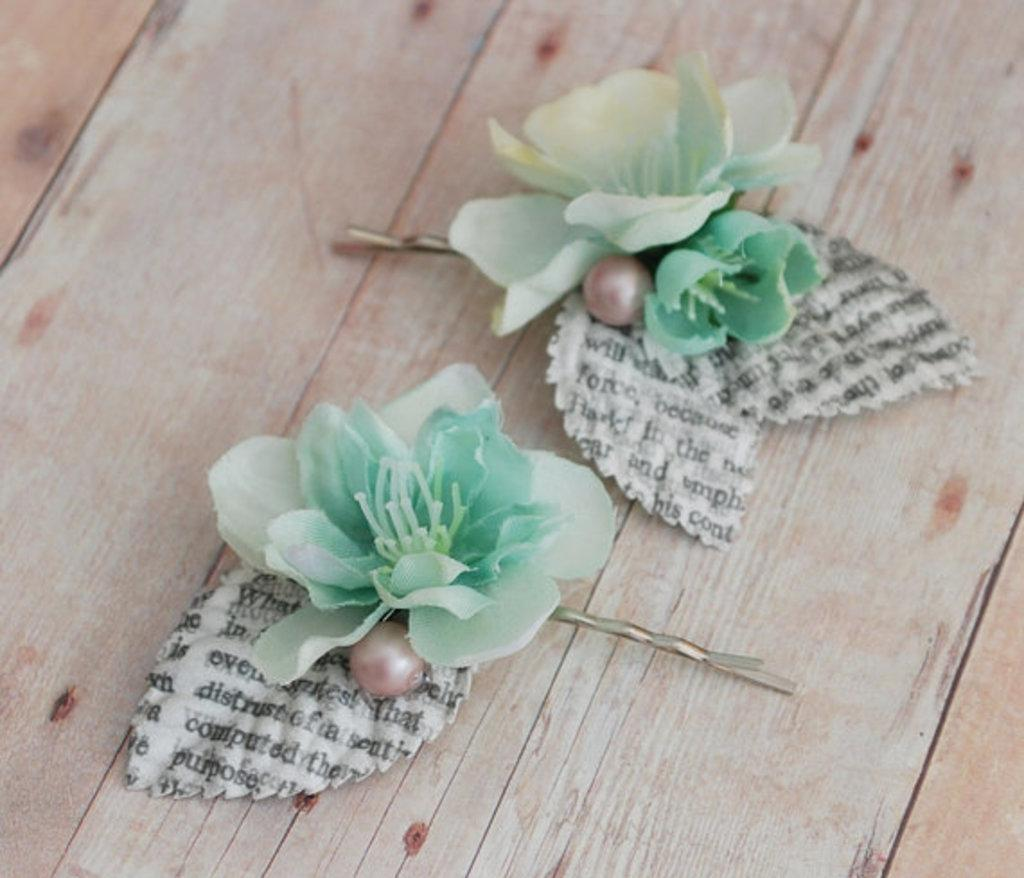What type of hair accessory is shown in the image? There are flower model hair pins in the image. Where are the hair pins placed in the image? The hair pins are on a wooden surface. What type of education does the grandmother in the image have? There is no grandmother present in the image. What type of utensil is used to eat food in the image? There is no utensil, such as a fork, present in the image. 